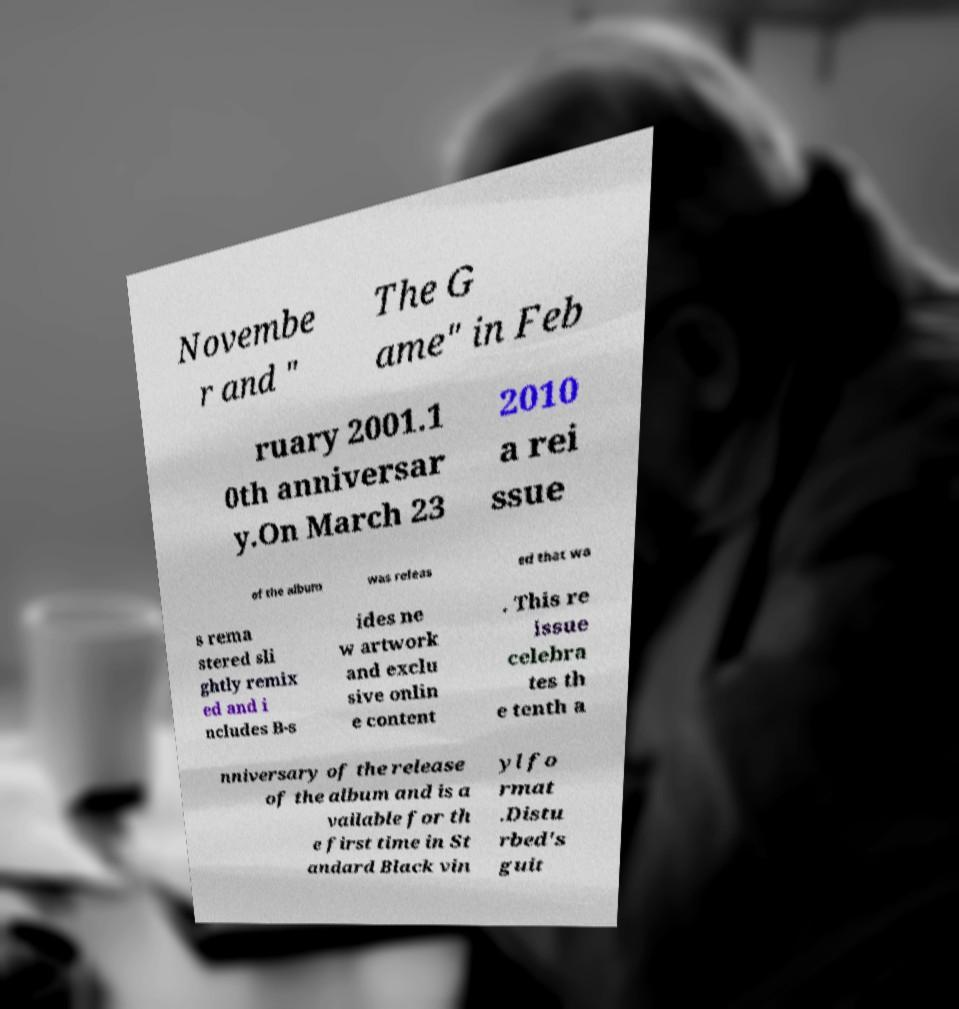Please identify and transcribe the text found in this image. Novembe r and " The G ame" in Feb ruary 2001.1 0th anniversar y.On March 23 2010 a rei ssue of the album was releas ed that wa s rema stered sli ghtly remix ed and i ncludes B-s ides ne w artwork and exclu sive onlin e content . This re issue celebra tes th e tenth a nniversary of the release of the album and is a vailable for th e first time in St andard Black vin yl fo rmat .Distu rbed's guit 